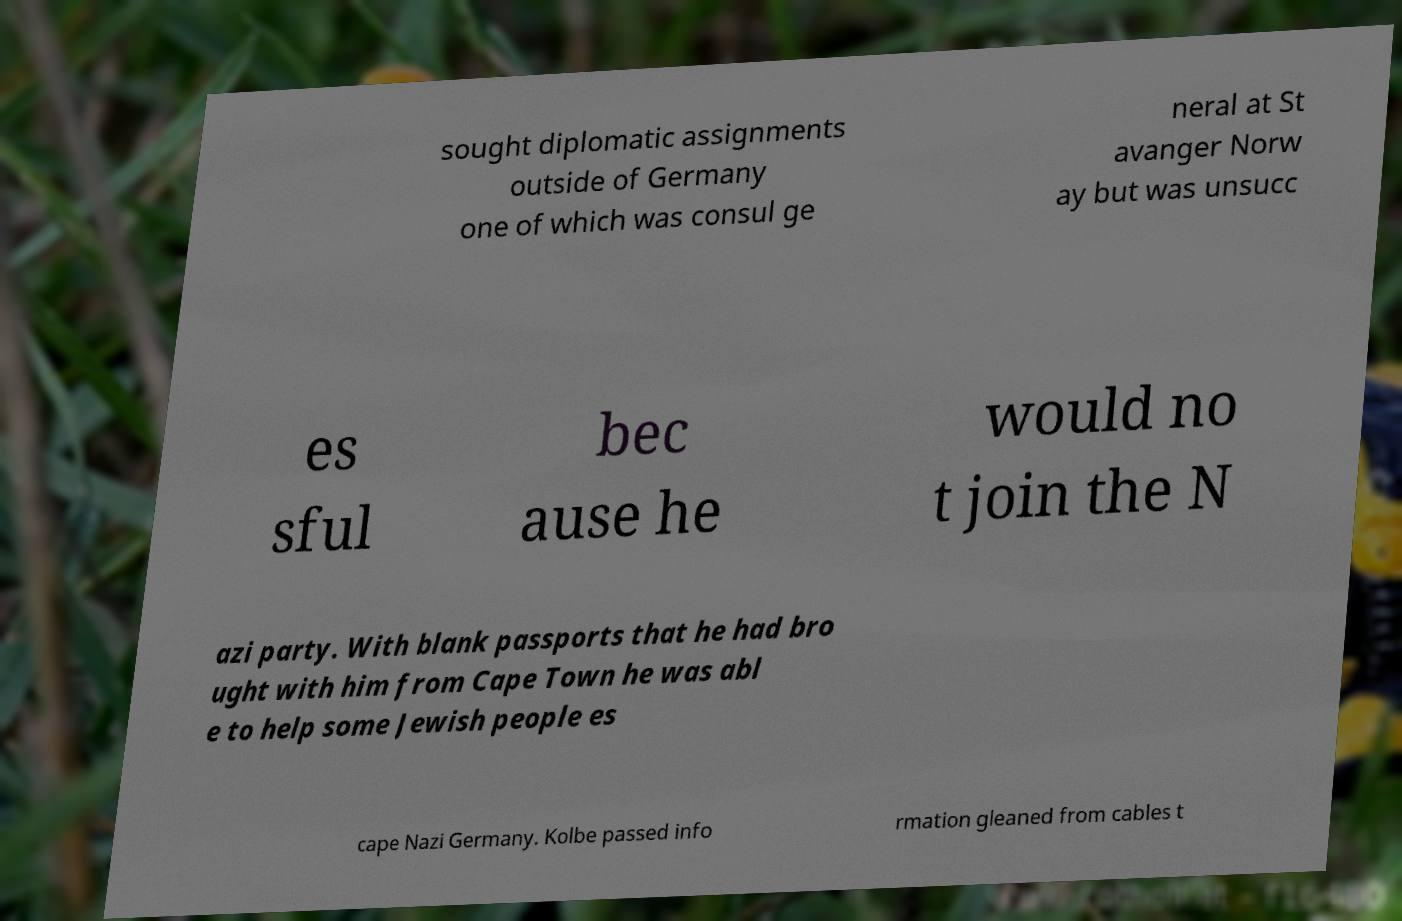For documentation purposes, I need the text within this image transcribed. Could you provide that? sought diplomatic assignments outside of Germany one of which was consul ge neral at St avanger Norw ay but was unsucc es sful bec ause he would no t join the N azi party. With blank passports that he had bro ught with him from Cape Town he was abl e to help some Jewish people es cape Nazi Germany. Kolbe passed info rmation gleaned from cables t 